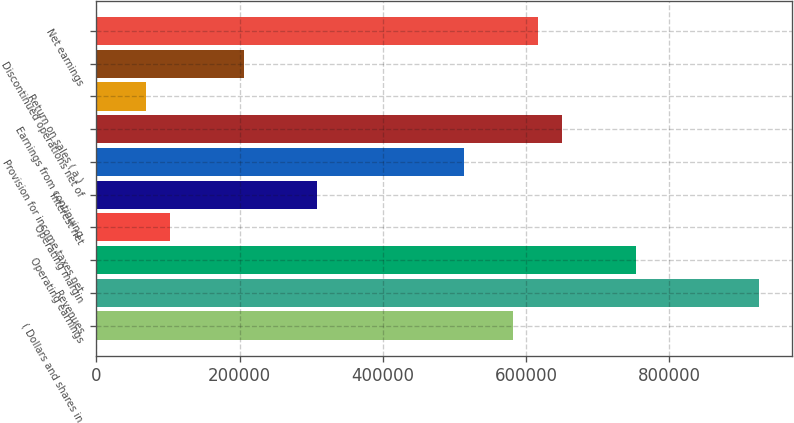<chart> <loc_0><loc_0><loc_500><loc_500><bar_chart><fcel>( Dollars and shares in<fcel>Revenues<fcel>Operating earnings<fcel>Operating margin<fcel>Interest net<fcel>Provision for income taxes net<fcel>Earnings from continuing<fcel>Return on sales ( a )<fcel>Discontinued operations net of<fcel>Net earnings<nl><fcel>582419<fcel>925018<fcel>753718<fcel>102781<fcel>308340<fcel>513899<fcel>650939<fcel>68521.1<fcel>205561<fcel>616679<nl></chart> 